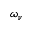<formula> <loc_0><loc_0><loc_500><loc_500>\omega _ { \nu }</formula> 